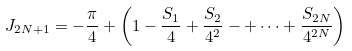<formula> <loc_0><loc_0><loc_500><loc_500>J _ { 2 N + 1 } = - \frac { \pi } { 4 } + \left ( 1 - \frac { S _ { 1 } } { 4 } + \frac { S _ { 2 } } { 4 ^ { 2 } } - + \cdots + \frac { S _ { 2 N } } { 4 ^ { 2 N } } \right )</formula> 